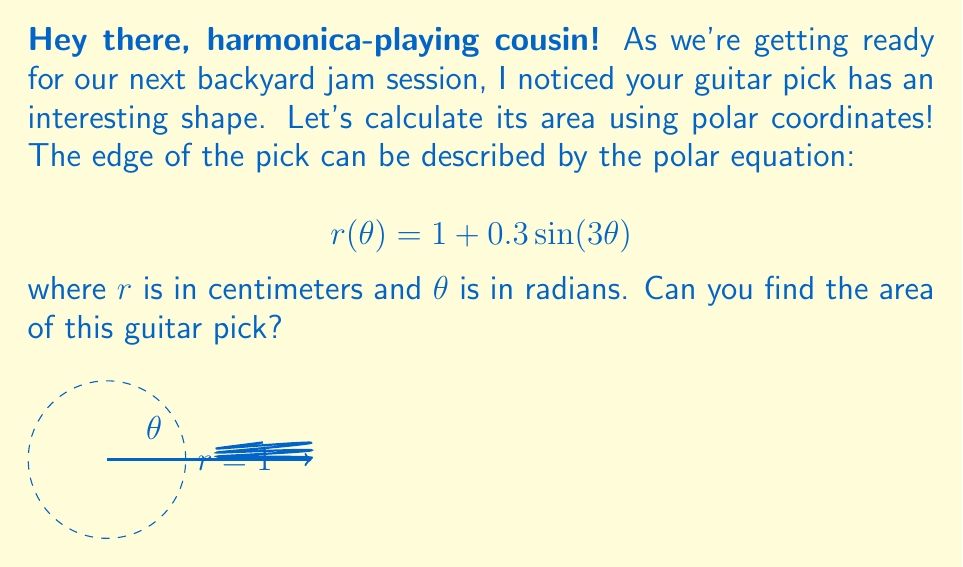Provide a solution to this math problem. Alright, let's break this down step-by-step:

1) The formula for the area of a region in polar coordinates is:

   $$A = \frac{1}{2}\int_0^{2\pi} [r(\theta)]^2 d\theta$$

2) We need to square our $r(\theta)$ function:

   $$[r(\theta)]^2 = [1 + 0.3\sin(3\theta)]^2$$
   $$= 1 + 0.6\sin(3\theta) + 0.09\sin^2(3\theta)$$

3) Now, let's set up our integral:

   $$A = \frac{1}{2}\int_0^{2\pi} [1 + 0.6\sin(3\theta) + 0.09\sin^2(3\theta)] d\theta$$

4) We can split this into three integrals:

   $$A = \frac{1}{2}\int_0^{2\pi} 1 d\theta + \frac{1}{2}\int_0^{2\pi} 0.6\sin(3\theta) d\theta + \frac{1}{2}\int_0^{2\pi} 0.09\sin^2(3\theta) d\theta$$

5) Evaluate each integral:
   - $\int_0^{2\pi} 1 d\theta = 2\pi$
   - $\int_0^{2\pi} \sin(3\theta) d\theta = 0$ (sine integrates to zero over a full period)
   - $\int_0^{2\pi} \sin^2(3\theta) d\theta = \pi$ (average value of $\sin^2$ is $\frac{1}{2}$ over a full period)

6) Putting it all together:

   $$A = \frac{1}{2}(2\pi + 0 + 0.09\pi) = \pi + 0.045\pi = 1.045\pi$$

7) Therefore, the area of the guitar pick is $1.045\pi$ square centimeters.
Answer: $1.045\pi$ cm² 